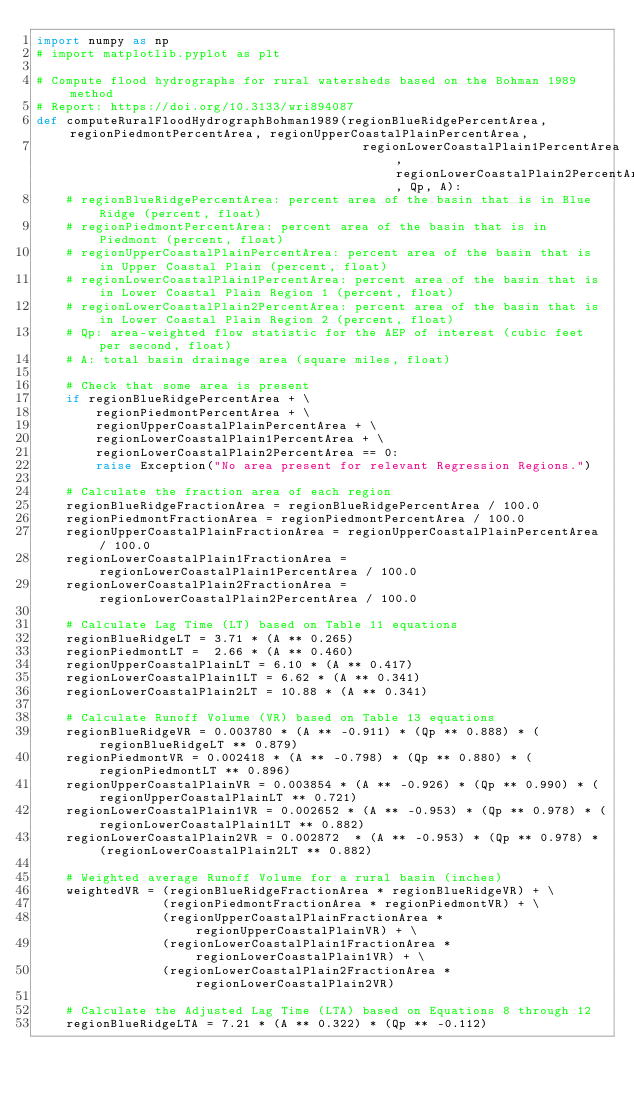Convert code to text. <code><loc_0><loc_0><loc_500><loc_500><_Python_>import numpy as np
# import matplotlib.pyplot as plt

# Compute flood hydrographs for rural watersheds based on the Bohman 1989 method
# Report: https://doi.org/10.3133/wri894087
def computeRuralFloodHydrographBohman1989(regionBlueRidgePercentArea, regionPiedmontPercentArea, regionUpperCoastalPlainPercentArea,
                                            regionLowerCoastalPlain1PercentArea, regionLowerCoastalPlain2PercentArea, Qp, A):
    # regionBlueRidgePercentArea: percent area of the basin that is in Blue Ridge (percent, float)
    # regionPiedmontPercentArea: percent area of the basin that is in Piedmont (percent, float)
    # regionUpperCoastalPlainPercentArea: percent area of the basin that is in Upper Coastal Plain (percent, float)
    # regionLowerCoastalPlain1PercentArea: percent area of the basin that is in Lower Coastal Plain Region 1 (percent, float)
    # regionLowerCoastalPlain2PercentArea: percent area of the basin that is in Lower Coastal Plain Region 2 (percent, float)
    # Qp: area-weighted flow statistic for the AEP of interest (cubic feet per second, float)
    # A: total basin drainage area (square miles, float)

    # Check that some area is present
    if regionBlueRidgePercentArea + \
        regionPiedmontPercentArea + \
        regionUpperCoastalPlainPercentArea + \
        regionLowerCoastalPlain1PercentArea + \
        regionLowerCoastalPlain2PercentArea == 0:
        raise Exception("No area present for relevant Regression Regions.")

    # Calculate the fraction area of each region
    regionBlueRidgeFractionArea = regionBlueRidgePercentArea / 100.0
    regionPiedmontFractionArea = regionPiedmontPercentArea / 100.0
    regionUpperCoastalPlainFractionArea = regionUpperCoastalPlainPercentArea / 100.0
    regionLowerCoastalPlain1FractionArea = regionLowerCoastalPlain1PercentArea / 100.0
    regionLowerCoastalPlain2FractionArea = regionLowerCoastalPlain2PercentArea / 100.0

    # Calculate Lag Time (LT) based on Table 11 equations
    regionBlueRidgeLT = 3.71 * (A ** 0.265)
    regionPiedmontLT =  2.66 * (A ** 0.460)
    regionUpperCoastalPlainLT = 6.10 * (A ** 0.417)
    regionLowerCoastalPlain1LT = 6.62 * (A ** 0.341)
    regionLowerCoastalPlain2LT = 10.88 * (A ** 0.341)

    # Calculate Runoff Volume (VR) based on Table 13 equations
    regionBlueRidgeVR = 0.003780 * (A ** -0.911) * (Qp ** 0.888) * (regionBlueRidgeLT ** 0.879)
    regionPiedmontVR = 0.002418 * (A ** -0.798) * (Qp ** 0.880) * (regionPiedmontLT ** 0.896)
    regionUpperCoastalPlainVR = 0.003854 * (A ** -0.926) * (Qp ** 0.990) * (regionUpperCoastalPlainLT ** 0.721)
    regionLowerCoastalPlain1VR = 0.002652 * (A ** -0.953) * (Qp ** 0.978) * (regionLowerCoastalPlain1LT ** 0.882)
    regionLowerCoastalPlain2VR = 0.002872  * (A ** -0.953) * (Qp ** 0.978) * (regionLowerCoastalPlain2LT ** 0.882)

    # Weighted average Runoff Volume for a rural basin (inches)
    weightedVR = (regionBlueRidgeFractionArea * regionBlueRidgeVR) + \
                 (regionPiedmontFractionArea * regionPiedmontVR) + \
                 (regionUpperCoastalPlainFractionArea * regionUpperCoastalPlainVR) + \
                 (regionLowerCoastalPlain1FractionArea * regionLowerCoastalPlain1VR) + \
                 (regionLowerCoastalPlain2FractionArea * regionLowerCoastalPlain2VR) 
    
    # Calculate the Adjusted Lag Time (LTA) based on Equations 8 through 12
    regionBlueRidgeLTA = 7.21 * (A ** 0.322) * (Qp ** -0.112)</code> 